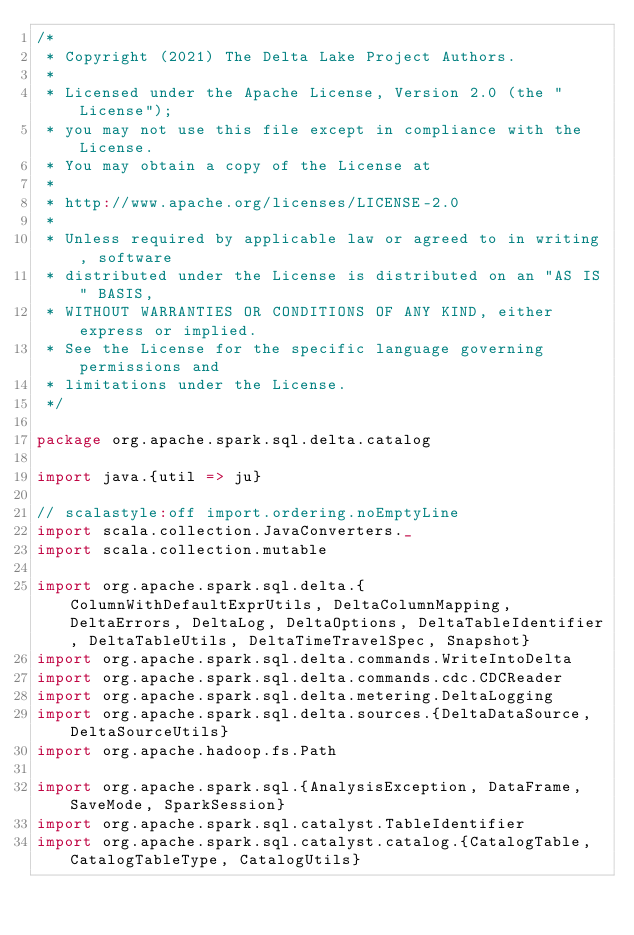Convert code to text. <code><loc_0><loc_0><loc_500><loc_500><_Scala_>/*
 * Copyright (2021) The Delta Lake Project Authors.
 *
 * Licensed under the Apache License, Version 2.0 (the "License");
 * you may not use this file except in compliance with the License.
 * You may obtain a copy of the License at
 *
 * http://www.apache.org/licenses/LICENSE-2.0
 *
 * Unless required by applicable law or agreed to in writing, software
 * distributed under the License is distributed on an "AS IS" BASIS,
 * WITHOUT WARRANTIES OR CONDITIONS OF ANY KIND, either express or implied.
 * See the License for the specific language governing permissions and
 * limitations under the License.
 */

package org.apache.spark.sql.delta.catalog

import java.{util => ju}

// scalastyle:off import.ordering.noEmptyLine
import scala.collection.JavaConverters._
import scala.collection.mutable

import org.apache.spark.sql.delta.{ColumnWithDefaultExprUtils, DeltaColumnMapping, DeltaErrors, DeltaLog, DeltaOptions, DeltaTableIdentifier, DeltaTableUtils, DeltaTimeTravelSpec, Snapshot}
import org.apache.spark.sql.delta.commands.WriteIntoDelta
import org.apache.spark.sql.delta.commands.cdc.CDCReader
import org.apache.spark.sql.delta.metering.DeltaLogging
import org.apache.spark.sql.delta.sources.{DeltaDataSource, DeltaSourceUtils}
import org.apache.hadoop.fs.Path

import org.apache.spark.sql.{AnalysisException, DataFrame, SaveMode, SparkSession}
import org.apache.spark.sql.catalyst.TableIdentifier
import org.apache.spark.sql.catalyst.catalog.{CatalogTable, CatalogTableType, CatalogUtils}</code> 